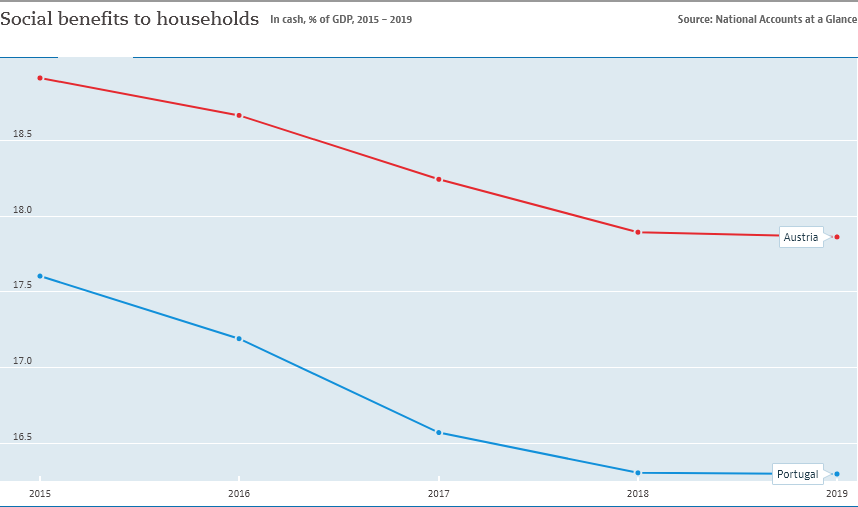Draw attention to some important aspects in this diagram. Austria is the country that provides the highest level of social benefits to households, relative to its GDP, compared to the other countries in the dataset. In 2018, the social benefits to households were lower than 18%. 